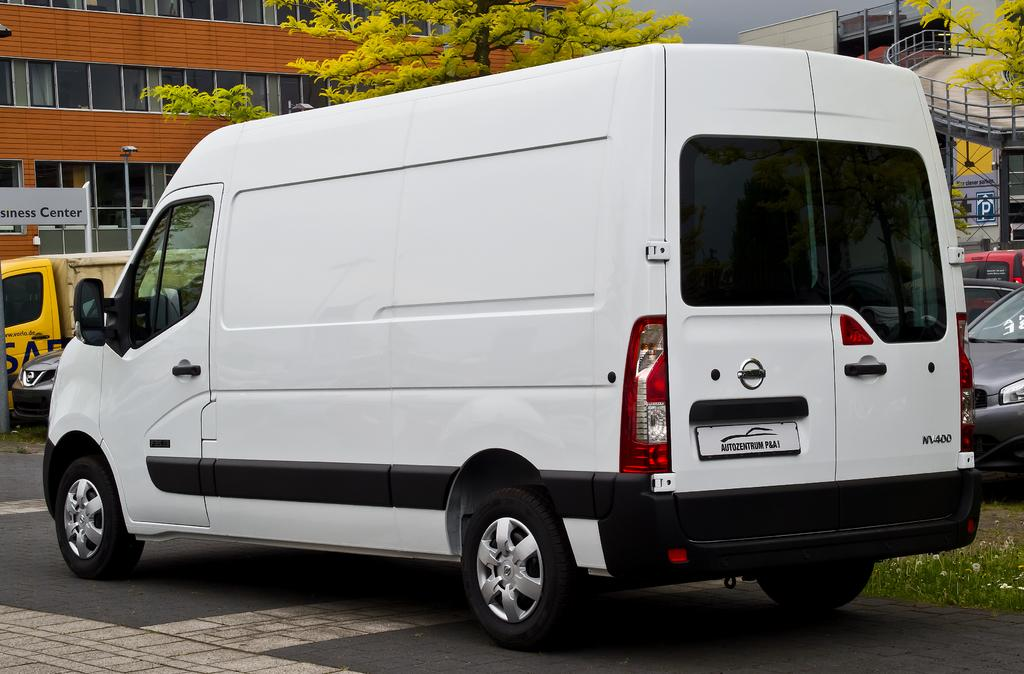What type of bag can be seen in the image? There is a white bag in the image. What kind of structure is present in the image? There is a building with windows in the image. What type of vegetation is visible in the image? There are trees in the image. What type of infrastructure is present in the image? There is a flyover in the image. What type of vehicles can be seen in the background of the image? Cars are visible in the background of the image. Can you tell me how many quince are on the flyover in the image? There are no quince present in the image; it features a white bag, a building with windows, trees, a flyover, and cars in the background. Is there a birth scene taking place in the image? There is no birth scene present in the image. 